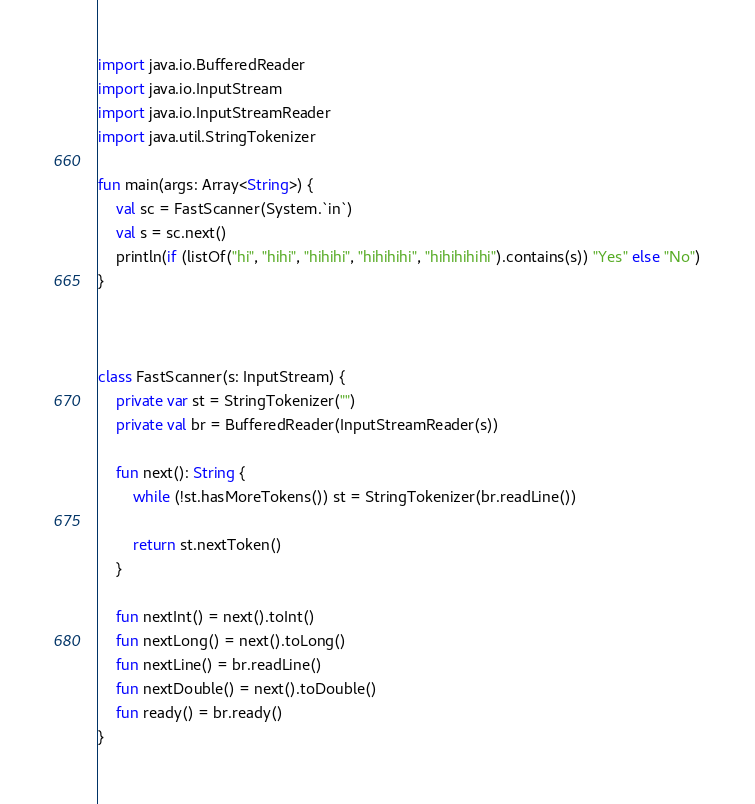<code> <loc_0><loc_0><loc_500><loc_500><_Kotlin_>import java.io.BufferedReader
import java.io.InputStream
import java.io.InputStreamReader
import java.util.StringTokenizer

fun main(args: Array<String>) {
    val sc = FastScanner(System.`in`)
    val s = sc.next()
    println(if (listOf("hi", "hihi", "hihihi", "hihihihi", "hihihihihi").contains(s)) "Yes" else "No")
}



class FastScanner(s: InputStream) {
    private var st = StringTokenizer("")
    private val br = BufferedReader(InputStreamReader(s))

    fun next(): String {
        while (!st.hasMoreTokens()) st = StringTokenizer(br.readLine())

        return st.nextToken()
    }

    fun nextInt() = next().toInt()
    fun nextLong() = next().toLong()
    fun nextLine() = br.readLine()
    fun nextDouble() = next().toDouble()
    fun ready() = br.ready()
}


</code> 